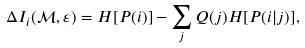Convert formula to latex. <formula><loc_0><loc_0><loc_500><loc_500>\Delta I _ { i } ( { \mathcal { M } } , \varepsilon ) = H [ P ( i ) ] - \sum _ { j } Q ( j ) H [ P ( i | j ) ] ,</formula> 